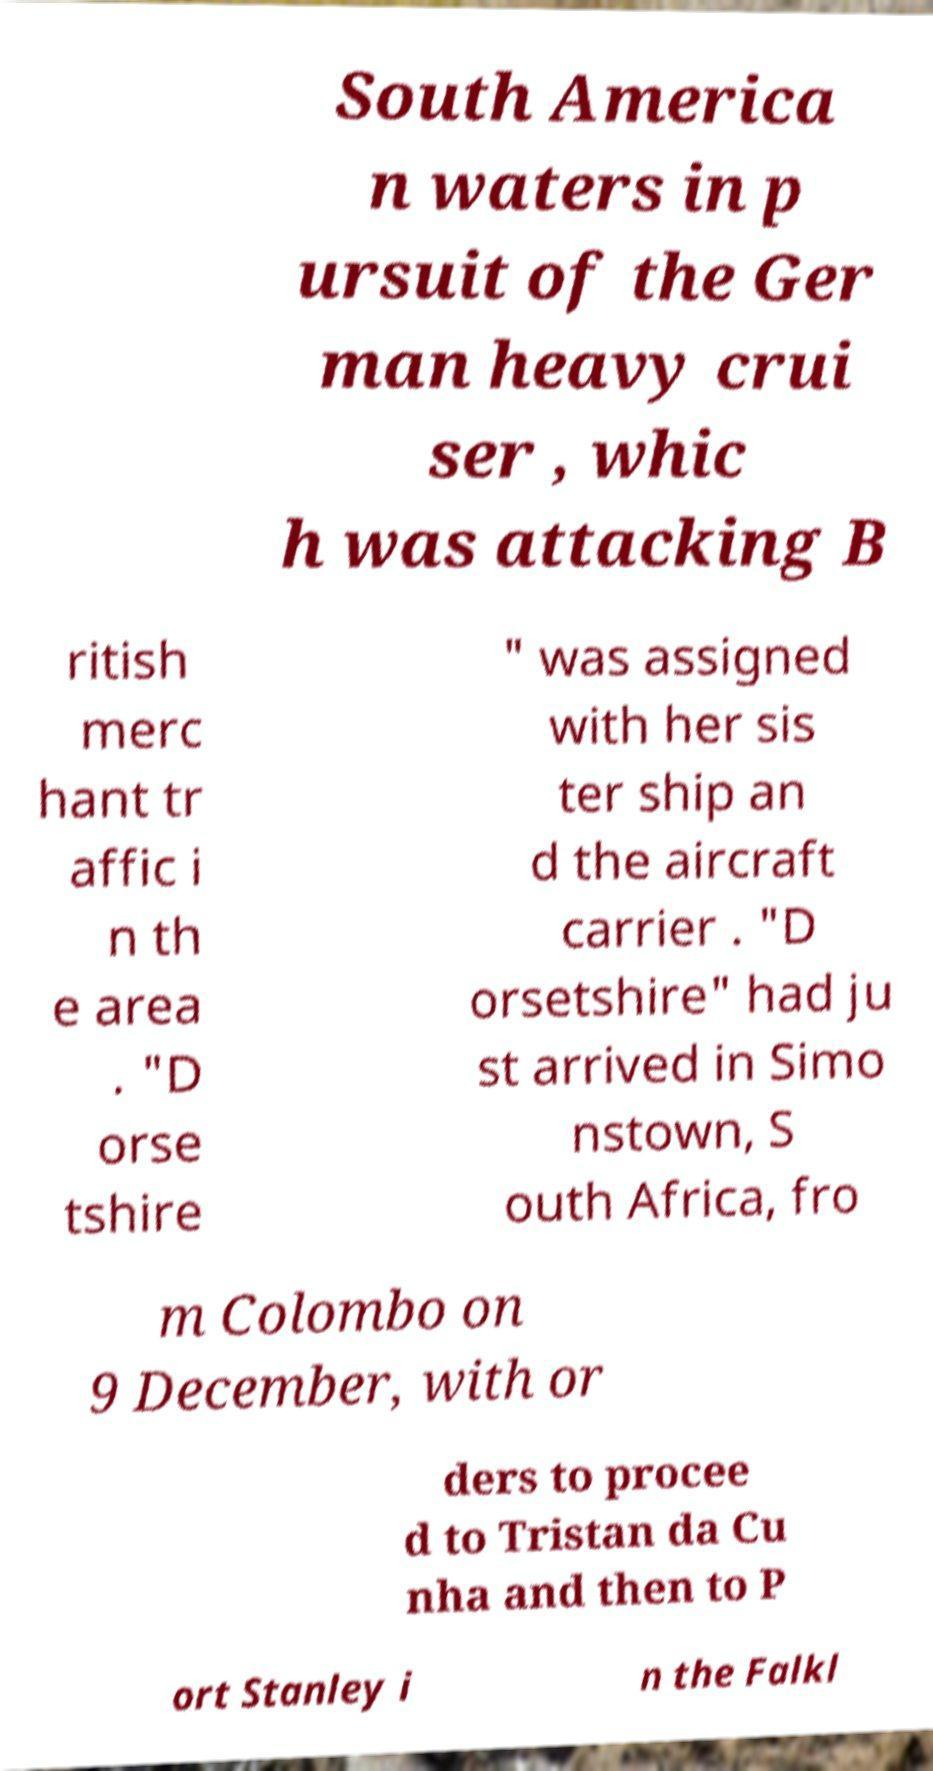For documentation purposes, I need the text within this image transcribed. Could you provide that? South America n waters in p ursuit of the Ger man heavy crui ser , whic h was attacking B ritish merc hant tr affic i n th e area . "D orse tshire " was assigned with her sis ter ship an d the aircraft carrier . "D orsetshire" had ju st arrived in Simo nstown, S outh Africa, fro m Colombo on 9 December, with or ders to procee d to Tristan da Cu nha and then to P ort Stanley i n the Falkl 